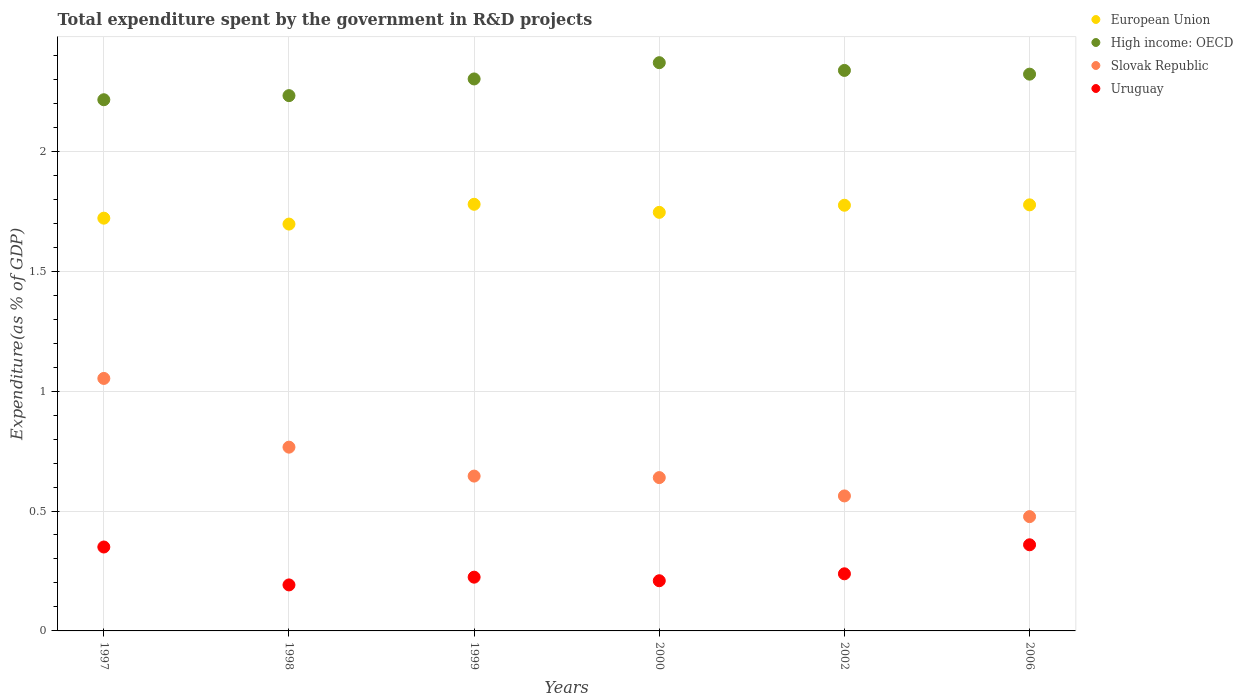Is the number of dotlines equal to the number of legend labels?
Provide a short and direct response. Yes. What is the total expenditure spent by the government in R&D projects in Slovak Republic in 1999?
Offer a very short reply. 0.65. Across all years, what is the maximum total expenditure spent by the government in R&D projects in European Union?
Ensure brevity in your answer.  1.78. Across all years, what is the minimum total expenditure spent by the government in R&D projects in Uruguay?
Keep it short and to the point. 0.19. In which year was the total expenditure spent by the government in R&D projects in Slovak Republic maximum?
Keep it short and to the point. 1997. What is the total total expenditure spent by the government in R&D projects in Slovak Republic in the graph?
Keep it short and to the point. 4.14. What is the difference between the total expenditure spent by the government in R&D projects in European Union in 2002 and that in 2006?
Offer a very short reply. -0. What is the difference between the total expenditure spent by the government in R&D projects in European Union in 2006 and the total expenditure spent by the government in R&D projects in Uruguay in 2002?
Provide a short and direct response. 1.54. What is the average total expenditure spent by the government in R&D projects in Uruguay per year?
Offer a very short reply. 0.26. In the year 2002, what is the difference between the total expenditure spent by the government in R&D projects in Uruguay and total expenditure spent by the government in R&D projects in High income: OECD?
Ensure brevity in your answer.  -2.1. In how many years, is the total expenditure spent by the government in R&D projects in High income: OECD greater than 1.7 %?
Your answer should be compact. 6. What is the ratio of the total expenditure spent by the government in R&D projects in High income: OECD in 1998 to that in 2002?
Make the answer very short. 0.96. Is the total expenditure spent by the government in R&D projects in European Union in 1998 less than that in 2006?
Make the answer very short. Yes. Is the difference between the total expenditure spent by the government in R&D projects in Uruguay in 1999 and 2000 greater than the difference between the total expenditure spent by the government in R&D projects in High income: OECD in 1999 and 2000?
Ensure brevity in your answer.  Yes. What is the difference between the highest and the second highest total expenditure spent by the government in R&D projects in Slovak Republic?
Provide a short and direct response. 0.29. What is the difference between the highest and the lowest total expenditure spent by the government in R&D projects in Slovak Republic?
Provide a short and direct response. 0.58. In how many years, is the total expenditure spent by the government in R&D projects in Slovak Republic greater than the average total expenditure spent by the government in R&D projects in Slovak Republic taken over all years?
Offer a very short reply. 2. Is the sum of the total expenditure spent by the government in R&D projects in Uruguay in 1999 and 2006 greater than the maximum total expenditure spent by the government in R&D projects in Slovak Republic across all years?
Your response must be concise. No. Is it the case that in every year, the sum of the total expenditure spent by the government in R&D projects in Uruguay and total expenditure spent by the government in R&D projects in Slovak Republic  is greater than the total expenditure spent by the government in R&D projects in European Union?
Keep it short and to the point. No. Does the total expenditure spent by the government in R&D projects in High income: OECD monotonically increase over the years?
Provide a short and direct response. No. Is the total expenditure spent by the government in R&D projects in European Union strictly greater than the total expenditure spent by the government in R&D projects in Slovak Republic over the years?
Your answer should be compact. Yes. How many dotlines are there?
Provide a succinct answer. 4. How many years are there in the graph?
Offer a terse response. 6. What is the difference between two consecutive major ticks on the Y-axis?
Give a very brief answer. 0.5. Are the values on the major ticks of Y-axis written in scientific E-notation?
Your answer should be very brief. No. Does the graph contain grids?
Your response must be concise. Yes. Where does the legend appear in the graph?
Provide a succinct answer. Top right. How many legend labels are there?
Make the answer very short. 4. What is the title of the graph?
Offer a terse response. Total expenditure spent by the government in R&D projects. What is the label or title of the Y-axis?
Ensure brevity in your answer.  Expenditure(as % of GDP). What is the Expenditure(as % of GDP) of European Union in 1997?
Offer a terse response. 1.72. What is the Expenditure(as % of GDP) of High income: OECD in 1997?
Offer a very short reply. 2.22. What is the Expenditure(as % of GDP) in Slovak Republic in 1997?
Offer a terse response. 1.05. What is the Expenditure(as % of GDP) in Uruguay in 1997?
Your answer should be very brief. 0.35. What is the Expenditure(as % of GDP) in European Union in 1998?
Make the answer very short. 1.7. What is the Expenditure(as % of GDP) of High income: OECD in 1998?
Your answer should be very brief. 2.23. What is the Expenditure(as % of GDP) of Slovak Republic in 1998?
Your answer should be very brief. 0.77. What is the Expenditure(as % of GDP) of Uruguay in 1998?
Your answer should be compact. 0.19. What is the Expenditure(as % of GDP) in European Union in 1999?
Make the answer very short. 1.78. What is the Expenditure(as % of GDP) of High income: OECD in 1999?
Your answer should be very brief. 2.3. What is the Expenditure(as % of GDP) of Slovak Republic in 1999?
Make the answer very short. 0.65. What is the Expenditure(as % of GDP) of Uruguay in 1999?
Provide a short and direct response. 0.22. What is the Expenditure(as % of GDP) of European Union in 2000?
Ensure brevity in your answer.  1.75. What is the Expenditure(as % of GDP) of High income: OECD in 2000?
Keep it short and to the point. 2.37. What is the Expenditure(as % of GDP) of Slovak Republic in 2000?
Your answer should be compact. 0.64. What is the Expenditure(as % of GDP) of Uruguay in 2000?
Your answer should be compact. 0.21. What is the Expenditure(as % of GDP) in European Union in 2002?
Give a very brief answer. 1.78. What is the Expenditure(as % of GDP) in High income: OECD in 2002?
Offer a very short reply. 2.34. What is the Expenditure(as % of GDP) of Slovak Republic in 2002?
Your answer should be very brief. 0.56. What is the Expenditure(as % of GDP) of Uruguay in 2002?
Your answer should be very brief. 0.24. What is the Expenditure(as % of GDP) in European Union in 2006?
Your answer should be very brief. 1.78. What is the Expenditure(as % of GDP) in High income: OECD in 2006?
Your answer should be very brief. 2.32. What is the Expenditure(as % of GDP) in Slovak Republic in 2006?
Your answer should be very brief. 0.48. What is the Expenditure(as % of GDP) of Uruguay in 2006?
Give a very brief answer. 0.36. Across all years, what is the maximum Expenditure(as % of GDP) of European Union?
Your response must be concise. 1.78. Across all years, what is the maximum Expenditure(as % of GDP) of High income: OECD?
Provide a succinct answer. 2.37. Across all years, what is the maximum Expenditure(as % of GDP) of Slovak Republic?
Make the answer very short. 1.05. Across all years, what is the maximum Expenditure(as % of GDP) in Uruguay?
Your answer should be compact. 0.36. Across all years, what is the minimum Expenditure(as % of GDP) of European Union?
Provide a short and direct response. 1.7. Across all years, what is the minimum Expenditure(as % of GDP) of High income: OECD?
Make the answer very short. 2.22. Across all years, what is the minimum Expenditure(as % of GDP) of Slovak Republic?
Your response must be concise. 0.48. Across all years, what is the minimum Expenditure(as % of GDP) of Uruguay?
Give a very brief answer. 0.19. What is the total Expenditure(as % of GDP) of European Union in the graph?
Keep it short and to the point. 10.49. What is the total Expenditure(as % of GDP) in High income: OECD in the graph?
Your answer should be compact. 13.78. What is the total Expenditure(as % of GDP) of Slovak Republic in the graph?
Provide a succinct answer. 4.14. What is the total Expenditure(as % of GDP) of Uruguay in the graph?
Ensure brevity in your answer.  1.57. What is the difference between the Expenditure(as % of GDP) in European Union in 1997 and that in 1998?
Provide a short and direct response. 0.02. What is the difference between the Expenditure(as % of GDP) in High income: OECD in 1997 and that in 1998?
Offer a very short reply. -0.02. What is the difference between the Expenditure(as % of GDP) of Slovak Republic in 1997 and that in 1998?
Give a very brief answer. 0.29. What is the difference between the Expenditure(as % of GDP) of Uruguay in 1997 and that in 1998?
Make the answer very short. 0.16. What is the difference between the Expenditure(as % of GDP) in European Union in 1997 and that in 1999?
Make the answer very short. -0.06. What is the difference between the Expenditure(as % of GDP) in High income: OECD in 1997 and that in 1999?
Offer a very short reply. -0.09. What is the difference between the Expenditure(as % of GDP) of Slovak Republic in 1997 and that in 1999?
Provide a succinct answer. 0.41. What is the difference between the Expenditure(as % of GDP) of Uruguay in 1997 and that in 1999?
Ensure brevity in your answer.  0.13. What is the difference between the Expenditure(as % of GDP) in European Union in 1997 and that in 2000?
Provide a short and direct response. -0.02. What is the difference between the Expenditure(as % of GDP) in High income: OECD in 1997 and that in 2000?
Provide a succinct answer. -0.15. What is the difference between the Expenditure(as % of GDP) of Slovak Republic in 1997 and that in 2000?
Offer a terse response. 0.41. What is the difference between the Expenditure(as % of GDP) in Uruguay in 1997 and that in 2000?
Offer a terse response. 0.14. What is the difference between the Expenditure(as % of GDP) of European Union in 1997 and that in 2002?
Ensure brevity in your answer.  -0.05. What is the difference between the Expenditure(as % of GDP) of High income: OECD in 1997 and that in 2002?
Ensure brevity in your answer.  -0.12. What is the difference between the Expenditure(as % of GDP) in Slovak Republic in 1997 and that in 2002?
Your response must be concise. 0.49. What is the difference between the Expenditure(as % of GDP) of Uruguay in 1997 and that in 2002?
Ensure brevity in your answer.  0.11. What is the difference between the Expenditure(as % of GDP) in European Union in 1997 and that in 2006?
Your response must be concise. -0.06. What is the difference between the Expenditure(as % of GDP) in High income: OECD in 1997 and that in 2006?
Your answer should be very brief. -0.11. What is the difference between the Expenditure(as % of GDP) of Slovak Republic in 1997 and that in 2006?
Make the answer very short. 0.58. What is the difference between the Expenditure(as % of GDP) of Uruguay in 1997 and that in 2006?
Make the answer very short. -0.01. What is the difference between the Expenditure(as % of GDP) in European Union in 1998 and that in 1999?
Your answer should be compact. -0.08. What is the difference between the Expenditure(as % of GDP) of High income: OECD in 1998 and that in 1999?
Make the answer very short. -0.07. What is the difference between the Expenditure(as % of GDP) in Slovak Republic in 1998 and that in 1999?
Your response must be concise. 0.12. What is the difference between the Expenditure(as % of GDP) in Uruguay in 1998 and that in 1999?
Offer a very short reply. -0.03. What is the difference between the Expenditure(as % of GDP) of European Union in 1998 and that in 2000?
Provide a succinct answer. -0.05. What is the difference between the Expenditure(as % of GDP) in High income: OECD in 1998 and that in 2000?
Give a very brief answer. -0.14. What is the difference between the Expenditure(as % of GDP) in Slovak Republic in 1998 and that in 2000?
Your answer should be compact. 0.13. What is the difference between the Expenditure(as % of GDP) in Uruguay in 1998 and that in 2000?
Provide a succinct answer. -0.02. What is the difference between the Expenditure(as % of GDP) of European Union in 1998 and that in 2002?
Ensure brevity in your answer.  -0.08. What is the difference between the Expenditure(as % of GDP) in High income: OECD in 1998 and that in 2002?
Provide a short and direct response. -0.11. What is the difference between the Expenditure(as % of GDP) of Slovak Republic in 1998 and that in 2002?
Provide a short and direct response. 0.2. What is the difference between the Expenditure(as % of GDP) in Uruguay in 1998 and that in 2002?
Your answer should be compact. -0.05. What is the difference between the Expenditure(as % of GDP) of European Union in 1998 and that in 2006?
Offer a terse response. -0.08. What is the difference between the Expenditure(as % of GDP) of High income: OECD in 1998 and that in 2006?
Offer a very short reply. -0.09. What is the difference between the Expenditure(as % of GDP) of Slovak Republic in 1998 and that in 2006?
Your response must be concise. 0.29. What is the difference between the Expenditure(as % of GDP) in Uruguay in 1998 and that in 2006?
Provide a succinct answer. -0.17. What is the difference between the Expenditure(as % of GDP) of European Union in 1999 and that in 2000?
Provide a succinct answer. 0.03. What is the difference between the Expenditure(as % of GDP) of High income: OECD in 1999 and that in 2000?
Offer a very short reply. -0.07. What is the difference between the Expenditure(as % of GDP) in Slovak Republic in 1999 and that in 2000?
Ensure brevity in your answer.  0.01. What is the difference between the Expenditure(as % of GDP) in Uruguay in 1999 and that in 2000?
Your answer should be compact. 0.01. What is the difference between the Expenditure(as % of GDP) of European Union in 1999 and that in 2002?
Provide a short and direct response. 0. What is the difference between the Expenditure(as % of GDP) in High income: OECD in 1999 and that in 2002?
Make the answer very short. -0.04. What is the difference between the Expenditure(as % of GDP) of Slovak Republic in 1999 and that in 2002?
Ensure brevity in your answer.  0.08. What is the difference between the Expenditure(as % of GDP) in Uruguay in 1999 and that in 2002?
Keep it short and to the point. -0.01. What is the difference between the Expenditure(as % of GDP) of European Union in 1999 and that in 2006?
Your answer should be compact. 0. What is the difference between the Expenditure(as % of GDP) in High income: OECD in 1999 and that in 2006?
Offer a very short reply. -0.02. What is the difference between the Expenditure(as % of GDP) of Slovak Republic in 1999 and that in 2006?
Provide a succinct answer. 0.17. What is the difference between the Expenditure(as % of GDP) in Uruguay in 1999 and that in 2006?
Your response must be concise. -0.14. What is the difference between the Expenditure(as % of GDP) in European Union in 2000 and that in 2002?
Offer a terse response. -0.03. What is the difference between the Expenditure(as % of GDP) in High income: OECD in 2000 and that in 2002?
Make the answer very short. 0.03. What is the difference between the Expenditure(as % of GDP) of Slovak Republic in 2000 and that in 2002?
Your answer should be compact. 0.08. What is the difference between the Expenditure(as % of GDP) of Uruguay in 2000 and that in 2002?
Offer a very short reply. -0.03. What is the difference between the Expenditure(as % of GDP) of European Union in 2000 and that in 2006?
Your response must be concise. -0.03. What is the difference between the Expenditure(as % of GDP) of High income: OECD in 2000 and that in 2006?
Keep it short and to the point. 0.05. What is the difference between the Expenditure(as % of GDP) in Slovak Republic in 2000 and that in 2006?
Provide a short and direct response. 0.16. What is the difference between the Expenditure(as % of GDP) of Uruguay in 2000 and that in 2006?
Provide a succinct answer. -0.15. What is the difference between the Expenditure(as % of GDP) of European Union in 2002 and that in 2006?
Make the answer very short. -0. What is the difference between the Expenditure(as % of GDP) of High income: OECD in 2002 and that in 2006?
Provide a succinct answer. 0.02. What is the difference between the Expenditure(as % of GDP) in Slovak Republic in 2002 and that in 2006?
Keep it short and to the point. 0.09. What is the difference between the Expenditure(as % of GDP) of Uruguay in 2002 and that in 2006?
Offer a very short reply. -0.12. What is the difference between the Expenditure(as % of GDP) in European Union in 1997 and the Expenditure(as % of GDP) in High income: OECD in 1998?
Make the answer very short. -0.51. What is the difference between the Expenditure(as % of GDP) of European Union in 1997 and the Expenditure(as % of GDP) of Slovak Republic in 1998?
Keep it short and to the point. 0.95. What is the difference between the Expenditure(as % of GDP) of European Union in 1997 and the Expenditure(as % of GDP) of Uruguay in 1998?
Provide a short and direct response. 1.53. What is the difference between the Expenditure(as % of GDP) in High income: OECD in 1997 and the Expenditure(as % of GDP) in Slovak Republic in 1998?
Provide a succinct answer. 1.45. What is the difference between the Expenditure(as % of GDP) in High income: OECD in 1997 and the Expenditure(as % of GDP) in Uruguay in 1998?
Your answer should be very brief. 2.02. What is the difference between the Expenditure(as % of GDP) of Slovak Republic in 1997 and the Expenditure(as % of GDP) of Uruguay in 1998?
Keep it short and to the point. 0.86. What is the difference between the Expenditure(as % of GDP) in European Union in 1997 and the Expenditure(as % of GDP) in High income: OECD in 1999?
Give a very brief answer. -0.58. What is the difference between the Expenditure(as % of GDP) in European Union in 1997 and the Expenditure(as % of GDP) in Slovak Republic in 1999?
Give a very brief answer. 1.08. What is the difference between the Expenditure(as % of GDP) in European Union in 1997 and the Expenditure(as % of GDP) in Uruguay in 1999?
Give a very brief answer. 1.5. What is the difference between the Expenditure(as % of GDP) in High income: OECD in 1997 and the Expenditure(as % of GDP) in Slovak Republic in 1999?
Provide a succinct answer. 1.57. What is the difference between the Expenditure(as % of GDP) of High income: OECD in 1997 and the Expenditure(as % of GDP) of Uruguay in 1999?
Offer a terse response. 1.99. What is the difference between the Expenditure(as % of GDP) of Slovak Republic in 1997 and the Expenditure(as % of GDP) of Uruguay in 1999?
Your answer should be compact. 0.83. What is the difference between the Expenditure(as % of GDP) in European Union in 1997 and the Expenditure(as % of GDP) in High income: OECD in 2000?
Give a very brief answer. -0.65. What is the difference between the Expenditure(as % of GDP) of European Union in 1997 and the Expenditure(as % of GDP) of Slovak Republic in 2000?
Keep it short and to the point. 1.08. What is the difference between the Expenditure(as % of GDP) in European Union in 1997 and the Expenditure(as % of GDP) in Uruguay in 2000?
Your answer should be very brief. 1.51. What is the difference between the Expenditure(as % of GDP) in High income: OECD in 1997 and the Expenditure(as % of GDP) in Slovak Republic in 2000?
Provide a short and direct response. 1.58. What is the difference between the Expenditure(as % of GDP) of High income: OECD in 1997 and the Expenditure(as % of GDP) of Uruguay in 2000?
Provide a short and direct response. 2.01. What is the difference between the Expenditure(as % of GDP) in Slovak Republic in 1997 and the Expenditure(as % of GDP) in Uruguay in 2000?
Keep it short and to the point. 0.84. What is the difference between the Expenditure(as % of GDP) of European Union in 1997 and the Expenditure(as % of GDP) of High income: OECD in 2002?
Offer a terse response. -0.62. What is the difference between the Expenditure(as % of GDP) of European Union in 1997 and the Expenditure(as % of GDP) of Slovak Republic in 2002?
Offer a terse response. 1.16. What is the difference between the Expenditure(as % of GDP) of European Union in 1997 and the Expenditure(as % of GDP) of Uruguay in 2002?
Your answer should be very brief. 1.48. What is the difference between the Expenditure(as % of GDP) in High income: OECD in 1997 and the Expenditure(as % of GDP) in Slovak Republic in 2002?
Keep it short and to the point. 1.65. What is the difference between the Expenditure(as % of GDP) in High income: OECD in 1997 and the Expenditure(as % of GDP) in Uruguay in 2002?
Keep it short and to the point. 1.98. What is the difference between the Expenditure(as % of GDP) of Slovak Republic in 1997 and the Expenditure(as % of GDP) of Uruguay in 2002?
Ensure brevity in your answer.  0.81. What is the difference between the Expenditure(as % of GDP) of European Union in 1997 and the Expenditure(as % of GDP) of High income: OECD in 2006?
Provide a succinct answer. -0.6. What is the difference between the Expenditure(as % of GDP) in European Union in 1997 and the Expenditure(as % of GDP) in Slovak Republic in 2006?
Keep it short and to the point. 1.24. What is the difference between the Expenditure(as % of GDP) of European Union in 1997 and the Expenditure(as % of GDP) of Uruguay in 2006?
Offer a very short reply. 1.36. What is the difference between the Expenditure(as % of GDP) of High income: OECD in 1997 and the Expenditure(as % of GDP) of Slovak Republic in 2006?
Offer a terse response. 1.74. What is the difference between the Expenditure(as % of GDP) of High income: OECD in 1997 and the Expenditure(as % of GDP) of Uruguay in 2006?
Offer a very short reply. 1.86. What is the difference between the Expenditure(as % of GDP) in Slovak Republic in 1997 and the Expenditure(as % of GDP) in Uruguay in 2006?
Give a very brief answer. 0.69. What is the difference between the Expenditure(as % of GDP) of European Union in 1998 and the Expenditure(as % of GDP) of High income: OECD in 1999?
Your response must be concise. -0.61. What is the difference between the Expenditure(as % of GDP) in European Union in 1998 and the Expenditure(as % of GDP) in Slovak Republic in 1999?
Provide a short and direct response. 1.05. What is the difference between the Expenditure(as % of GDP) in European Union in 1998 and the Expenditure(as % of GDP) in Uruguay in 1999?
Your response must be concise. 1.47. What is the difference between the Expenditure(as % of GDP) of High income: OECD in 1998 and the Expenditure(as % of GDP) of Slovak Republic in 1999?
Your answer should be compact. 1.59. What is the difference between the Expenditure(as % of GDP) in High income: OECD in 1998 and the Expenditure(as % of GDP) in Uruguay in 1999?
Offer a terse response. 2.01. What is the difference between the Expenditure(as % of GDP) in Slovak Republic in 1998 and the Expenditure(as % of GDP) in Uruguay in 1999?
Your response must be concise. 0.54. What is the difference between the Expenditure(as % of GDP) of European Union in 1998 and the Expenditure(as % of GDP) of High income: OECD in 2000?
Offer a very short reply. -0.67. What is the difference between the Expenditure(as % of GDP) of European Union in 1998 and the Expenditure(as % of GDP) of Slovak Republic in 2000?
Ensure brevity in your answer.  1.06. What is the difference between the Expenditure(as % of GDP) in European Union in 1998 and the Expenditure(as % of GDP) in Uruguay in 2000?
Offer a terse response. 1.49. What is the difference between the Expenditure(as % of GDP) of High income: OECD in 1998 and the Expenditure(as % of GDP) of Slovak Republic in 2000?
Provide a short and direct response. 1.59. What is the difference between the Expenditure(as % of GDP) of High income: OECD in 1998 and the Expenditure(as % of GDP) of Uruguay in 2000?
Provide a short and direct response. 2.02. What is the difference between the Expenditure(as % of GDP) of Slovak Republic in 1998 and the Expenditure(as % of GDP) of Uruguay in 2000?
Provide a short and direct response. 0.56. What is the difference between the Expenditure(as % of GDP) of European Union in 1998 and the Expenditure(as % of GDP) of High income: OECD in 2002?
Your answer should be very brief. -0.64. What is the difference between the Expenditure(as % of GDP) of European Union in 1998 and the Expenditure(as % of GDP) of Slovak Republic in 2002?
Your answer should be very brief. 1.13. What is the difference between the Expenditure(as % of GDP) in European Union in 1998 and the Expenditure(as % of GDP) in Uruguay in 2002?
Give a very brief answer. 1.46. What is the difference between the Expenditure(as % of GDP) of High income: OECD in 1998 and the Expenditure(as % of GDP) of Slovak Republic in 2002?
Provide a succinct answer. 1.67. What is the difference between the Expenditure(as % of GDP) in High income: OECD in 1998 and the Expenditure(as % of GDP) in Uruguay in 2002?
Offer a terse response. 1.99. What is the difference between the Expenditure(as % of GDP) in Slovak Republic in 1998 and the Expenditure(as % of GDP) in Uruguay in 2002?
Your response must be concise. 0.53. What is the difference between the Expenditure(as % of GDP) in European Union in 1998 and the Expenditure(as % of GDP) in High income: OECD in 2006?
Keep it short and to the point. -0.63. What is the difference between the Expenditure(as % of GDP) of European Union in 1998 and the Expenditure(as % of GDP) of Slovak Republic in 2006?
Keep it short and to the point. 1.22. What is the difference between the Expenditure(as % of GDP) of European Union in 1998 and the Expenditure(as % of GDP) of Uruguay in 2006?
Your response must be concise. 1.34. What is the difference between the Expenditure(as % of GDP) of High income: OECD in 1998 and the Expenditure(as % of GDP) of Slovak Republic in 2006?
Give a very brief answer. 1.76. What is the difference between the Expenditure(as % of GDP) of High income: OECD in 1998 and the Expenditure(as % of GDP) of Uruguay in 2006?
Ensure brevity in your answer.  1.87. What is the difference between the Expenditure(as % of GDP) of Slovak Republic in 1998 and the Expenditure(as % of GDP) of Uruguay in 2006?
Offer a terse response. 0.41. What is the difference between the Expenditure(as % of GDP) of European Union in 1999 and the Expenditure(as % of GDP) of High income: OECD in 2000?
Offer a terse response. -0.59. What is the difference between the Expenditure(as % of GDP) of European Union in 1999 and the Expenditure(as % of GDP) of Slovak Republic in 2000?
Ensure brevity in your answer.  1.14. What is the difference between the Expenditure(as % of GDP) of European Union in 1999 and the Expenditure(as % of GDP) of Uruguay in 2000?
Keep it short and to the point. 1.57. What is the difference between the Expenditure(as % of GDP) of High income: OECD in 1999 and the Expenditure(as % of GDP) of Slovak Republic in 2000?
Offer a terse response. 1.66. What is the difference between the Expenditure(as % of GDP) in High income: OECD in 1999 and the Expenditure(as % of GDP) in Uruguay in 2000?
Your answer should be compact. 2.09. What is the difference between the Expenditure(as % of GDP) of Slovak Republic in 1999 and the Expenditure(as % of GDP) of Uruguay in 2000?
Offer a terse response. 0.44. What is the difference between the Expenditure(as % of GDP) in European Union in 1999 and the Expenditure(as % of GDP) in High income: OECD in 2002?
Make the answer very short. -0.56. What is the difference between the Expenditure(as % of GDP) of European Union in 1999 and the Expenditure(as % of GDP) of Slovak Republic in 2002?
Offer a terse response. 1.22. What is the difference between the Expenditure(as % of GDP) of European Union in 1999 and the Expenditure(as % of GDP) of Uruguay in 2002?
Provide a short and direct response. 1.54. What is the difference between the Expenditure(as % of GDP) of High income: OECD in 1999 and the Expenditure(as % of GDP) of Slovak Republic in 2002?
Provide a short and direct response. 1.74. What is the difference between the Expenditure(as % of GDP) of High income: OECD in 1999 and the Expenditure(as % of GDP) of Uruguay in 2002?
Ensure brevity in your answer.  2.06. What is the difference between the Expenditure(as % of GDP) in Slovak Republic in 1999 and the Expenditure(as % of GDP) in Uruguay in 2002?
Ensure brevity in your answer.  0.41. What is the difference between the Expenditure(as % of GDP) in European Union in 1999 and the Expenditure(as % of GDP) in High income: OECD in 2006?
Your response must be concise. -0.54. What is the difference between the Expenditure(as % of GDP) of European Union in 1999 and the Expenditure(as % of GDP) of Slovak Republic in 2006?
Offer a terse response. 1.3. What is the difference between the Expenditure(as % of GDP) of European Union in 1999 and the Expenditure(as % of GDP) of Uruguay in 2006?
Give a very brief answer. 1.42. What is the difference between the Expenditure(as % of GDP) of High income: OECD in 1999 and the Expenditure(as % of GDP) of Slovak Republic in 2006?
Keep it short and to the point. 1.83. What is the difference between the Expenditure(as % of GDP) in High income: OECD in 1999 and the Expenditure(as % of GDP) in Uruguay in 2006?
Give a very brief answer. 1.94. What is the difference between the Expenditure(as % of GDP) in Slovak Republic in 1999 and the Expenditure(as % of GDP) in Uruguay in 2006?
Make the answer very short. 0.29. What is the difference between the Expenditure(as % of GDP) of European Union in 2000 and the Expenditure(as % of GDP) of High income: OECD in 2002?
Your response must be concise. -0.59. What is the difference between the Expenditure(as % of GDP) in European Union in 2000 and the Expenditure(as % of GDP) in Slovak Republic in 2002?
Offer a terse response. 1.18. What is the difference between the Expenditure(as % of GDP) of European Union in 2000 and the Expenditure(as % of GDP) of Uruguay in 2002?
Keep it short and to the point. 1.51. What is the difference between the Expenditure(as % of GDP) in High income: OECD in 2000 and the Expenditure(as % of GDP) in Slovak Republic in 2002?
Make the answer very short. 1.81. What is the difference between the Expenditure(as % of GDP) in High income: OECD in 2000 and the Expenditure(as % of GDP) in Uruguay in 2002?
Your response must be concise. 2.13. What is the difference between the Expenditure(as % of GDP) in Slovak Republic in 2000 and the Expenditure(as % of GDP) in Uruguay in 2002?
Provide a succinct answer. 0.4. What is the difference between the Expenditure(as % of GDP) of European Union in 2000 and the Expenditure(as % of GDP) of High income: OECD in 2006?
Offer a very short reply. -0.58. What is the difference between the Expenditure(as % of GDP) of European Union in 2000 and the Expenditure(as % of GDP) of Slovak Republic in 2006?
Provide a short and direct response. 1.27. What is the difference between the Expenditure(as % of GDP) in European Union in 2000 and the Expenditure(as % of GDP) in Uruguay in 2006?
Offer a terse response. 1.39. What is the difference between the Expenditure(as % of GDP) of High income: OECD in 2000 and the Expenditure(as % of GDP) of Slovak Republic in 2006?
Give a very brief answer. 1.89. What is the difference between the Expenditure(as % of GDP) in High income: OECD in 2000 and the Expenditure(as % of GDP) in Uruguay in 2006?
Your answer should be very brief. 2.01. What is the difference between the Expenditure(as % of GDP) in Slovak Republic in 2000 and the Expenditure(as % of GDP) in Uruguay in 2006?
Your response must be concise. 0.28. What is the difference between the Expenditure(as % of GDP) in European Union in 2002 and the Expenditure(as % of GDP) in High income: OECD in 2006?
Provide a short and direct response. -0.55. What is the difference between the Expenditure(as % of GDP) in European Union in 2002 and the Expenditure(as % of GDP) in Slovak Republic in 2006?
Make the answer very short. 1.3. What is the difference between the Expenditure(as % of GDP) in European Union in 2002 and the Expenditure(as % of GDP) in Uruguay in 2006?
Your answer should be compact. 1.42. What is the difference between the Expenditure(as % of GDP) in High income: OECD in 2002 and the Expenditure(as % of GDP) in Slovak Republic in 2006?
Offer a very short reply. 1.86. What is the difference between the Expenditure(as % of GDP) in High income: OECD in 2002 and the Expenditure(as % of GDP) in Uruguay in 2006?
Offer a very short reply. 1.98. What is the difference between the Expenditure(as % of GDP) of Slovak Republic in 2002 and the Expenditure(as % of GDP) of Uruguay in 2006?
Keep it short and to the point. 0.2. What is the average Expenditure(as % of GDP) in European Union per year?
Your response must be concise. 1.75. What is the average Expenditure(as % of GDP) in High income: OECD per year?
Provide a succinct answer. 2.3. What is the average Expenditure(as % of GDP) in Slovak Republic per year?
Provide a succinct answer. 0.69. What is the average Expenditure(as % of GDP) of Uruguay per year?
Provide a succinct answer. 0.26. In the year 1997, what is the difference between the Expenditure(as % of GDP) of European Union and Expenditure(as % of GDP) of High income: OECD?
Keep it short and to the point. -0.49. In the year 1997, what is the difference between the Expenditure(as % of GDP) of European Union and Expenditure(as % of GDP) of Slovak Republic?
Provide a short and direct response. 0.67. In the year 1997, what is the difference between the Expenditure(as % of GDP) in European Union and Expenditure(as % of GDP) in Uruguay?
Your response must be concise. 1.37. In the year 1997, what is the difference between the Expenditure(as % of GDP) of High income: OECD and Expenditure(as % of GDP) of Slovak Republic?
Offer a terse response. 1.16. In the year 1997, what is the difference between the Expenditure(as % of GDP) in High income: OECD and Expenditure(as % of GDP) in Uruguay?
Give a very brief answer. 1.87. In the year 1997, what is the difference between the Expenditure(as % of GDP) in Slovak Republic and Expenditure(as % of GDP) in Uruguay?
Offer a terse response. 0.7. In the year 1998, what is the difference between the Expenditure(as % of GDP) of European Union and Expenditure(as % of GDP) of High income: OECD?
Offer a very short reply. -0.54. In the year 1998, what is the difference between the Expenditure(as % of GDP) of European Union and Expenditure(as % of GDP) of Slovak Republic?
Give a very brief answer. 0.93. In the year 1998, what is the difference between the Expenditure(as % of GDP) of European Union and Expenditure(as % of GDP) of Uruguay?
Keep it short and to the point. 1.5. In the year 1998, what is the difference between the Expenditure(as % of GDP) in High income: OECD and Expenditure(as % of GDP) in Slovak Republic?
Your response must be concise. 1.47. In the year 1998, what is the difference between the Expenditure(as % of GDP) of High income: OECD and Expenditure(as % of GDP) of Uruguay?
Provide a succinct answer. 2.04. In the year 1998, what is the difference between the Expenditure(as % of GDP) in Slovak Republic and Expenditure(as % of GDP) in Uruguay?
Your answer should be compact. 0.57. In the year 1999, what is the difference between the Expenditure(as % of GDP) in European Union and Expenditure(as % of GDP) in High income: OECD?
Make the answer very short. -0.52. In the year 1999, what is the difference between the Expenditure(as % of GDP) of European Union and Expenditure(as % of GDP) of Slovak Republic?
Make the answer very short. 1.13. In the year 1999, what is the difference between the Expenditure(as % of GDP) of European Union and Expenditure(as % of GDP) of Uruguay?
Make the answer very short. 1.55. In the year 1999, what is the difference between the Expenditure(as % of GDP) of High income: OECD and Expenditure(as % of GDP) of Slovak Republic?
Your response must be concise. 1.66. In the year 1999, what is the difference between the Expenditure(as % of GDP) of High income: OECD and Expenditure(as % of GDP) of Uruguay?
Make the answer very short. 2.08. In the year 1999, what is the difference between the Expenditure(as % of GDP) in Slovak Republic and Expenditure(as % of GDP) in Uruguay?
Give a very brief answer. 0.42. In the year 2000, what is the difference between the Expenditure(as % of GDP) in European Union and Expenditure(as % of GDP) in High income: OECD?
Ensure brevity in your answer.  -0.62. In the year 2000, what is the difference between the Expenditure(as % of GDP) of European Union and Expenditure(as % of GDP) of Slovak Republic?
Ensure brevity in your answer.  1.11. In the year 2000, what is the difference between the Expenditure(as % of GDP) of European Union and Expenditure(as % of GDP) of Uruguay?
Your response must be concise. 1.54. In the year 2000, what is the difference between the Expenditure(as % of GDP) of High income: OECD and Expenditure(as % of GDP) of Slovak Republic?
Make the answer very short. 1.73. In the year 2000, what is the difference between the Expenditure(as % of GDP) in High income: OECD and Expenditure(as % of GDP) in Uruguay?
Ensure brevity in your answer.  2.16. In the year 2000, what is the difference between the Expenditure(as % of GDP) in Slovak Republic and Expenditure(as % of GDP) in Uruguay?
Your response must be concise. 0.43. In the year 2002, what is the difference between the Expenditure(as % of GDP) of European Union and Expenditure(as % of GDP) of High income: OECD?
Your answer should be very brief. -0.56. In the year 2002, what is the difference between the Expenditure(as % of GDP) of European Union and Expenditure(as % of GDP) of Slovak Republic?
Make the answer very short. 1.21. In the year 2002, what is the difference between the Expenditure(as % of GDP) of European Union and Expenditure(as % of GDP) of Uruguay?
Offer a very short reply. 1.54. In the year 2002, what is the difference between the Expenditure(as % of GDP) in High income: OECD and Expenditure(as % of GDP) in Slovak Republic?
Your answer should be very brief. 1.77. In the year 2002, what is the difference between the Expenditure(as % of GDP) of High income: OECD and Expenditure(as % of GDP) of Uruguay?
Your answer should be compact. 2.1. In the year 2002, what is the difference between the Expenditure(as % of GDP) in Slovak Republic and Expenditure(as % of GDP) in Uruguay?
Offer a very short reply. 0.32. In the year 2006, what is the difference between the Expenditure(as % of GDP) of European Union and Expenditure(as % of GDP) of High income: OECD?
Ensure brevity in your answer.  -0.55. In the year 2006, what is the difference between the Expenditure(as % of GDP) in European Union and Expenditure(as % of GDP) in Slovak Republic?
Make the answer very short. 1.3. In the year 2006, what is the difference between the Expenditure(as % of GDP) of European Union and Expenditure(as % of GDP) of Uruguay?
Provide a succinct answer. 1.42. In the year 2006, what is the difference between the Expenditure(as % of GDP) in High income: OECD and Expenditure(as % of GDP) in Slovak Republic?
Your answer should be very brief. 1.85. In the year 2006, what is the difference between the Expenditure(as % of GDP) in High income: OECD and Expenditure(as % of GDP) in Uruguay?
Offer a very short reply. 1.96. In the year 2006, what is the difference between the Expenditure(as % of GDP) in Slovak Republic and Expenditure(as % of GDP) in Uruguay?
Provide a short and direct response. 0.12. What is the ratio of the Expenditure(as % of GDP) of European Union in 1997 to that in 1998?
Your response must be concise. 1.01. What is the ratio of the Expenditure(as % of GDP) in High income: OECD in 1997 to that in 1998?
Offer a terse response. 0.99. What is the ratio of the Expenditure(as % of GDP) of Slovak Republic in 1997 to that in 1998?
Offer a very short reply. 1.37. What is the ratio of the Expenditure(as % of GDP) of Uruguay in 1997 to that in 1998?
Make the answer very short. 1.82. What is the ratio of the Expenditure(as % of GDP) in European Union in 1997 to that in 1999?
Provide a succinct answer. 0.97. What is the ratio of the Expenditure(as % of GDP) in High income: OECD in 1997 to that in 1999?
Offer a very short reply. 0.96. What is the ratio of the Expenditure(as % of GDP) of Slovak Republic in 1997 to that in 1999?
Keep it short and to the point. 1.63. What is the ratio of the Expenditure(as % of GDP) of Uruguay in 1997 to that in 1999?
Provide a short and direct response. 1.56. What is the ratio of the Expenditure(as % of GDP) in European Union in 1997 to that in 2000?
Offer a very short reply. 0.99. What is the ratio of the Expenditure(as % of GDP) in High income: OECD in 1997 to that in 2000?
Offer a terse response. 0.93. What is the ratio of the Expenditure(as % of GDP) of Slovak Republic in 1997 to that in 2000?
Your answer should be compact. 1.65. What is the ratio of the Expenditure(as % of GDP) of Uruguay in 1997 to that in 2000?
Your response must be concise. 1.67. What is the ratio of the Expenditure(as % of GDP) in European Union in 1997 to that in 2002?
Offer a terse response. 0.97. What is the ratio of the Expenditure(as % of GDP) in High income: OECD in 1997 to that in 2002?
Your answer should be very brief. 0.95. What is the ratio of the Expenditure(as % of GDP) in Slovak Republic in 1997 to that in 2002?
Offer a very short reply. 1.87. What is the ratio of the Expenditure(as % of GDP) in Uruguay in 1997 to that in 2002?
Your answer should be compact. 1.47. What is the ratio of the Expenditure(as % of GDP) in European Union in 1997 to that in 2006?
Offer a very short reply. 0.97. What is the ratio of the Expenditure(as % of GDP) of High income: OECD in 1997 to that in 2006?
Make the answer very short. 0.95. What is the ratio of the Expenditure(as % of GDP) in Slovak Republic in 1997 to that in 2006?
Your answer should be very brief. 2.21. What is the ratio of the Expenditure(as % of GDP) in Uruguay in 1997 to that in 2006?
Offer a very short reply. 0.97. What is the ratio of the Expenditure(as % of GDP) in European Union in 1998 to that in 1999?
Your response must be concise. 0.95. What is the ratio of the Expenditure(as % of GDP) of High income: OECD in 1998 to that in 1999?
Give a very brief answer. 0.97. What is the ratio of the Expenditure(as % of GDP) in Slovak Republic in 1998 to that in 1999?
Your response must be concise. 1.19. What is the ratio of the Expenditure(as % of GDP) of Uruguay in 1998 to that in 1999?
Your answer should be very brief. 0.86. What is the ratio of the Expenditure(as % of GDP) of High income: OECD in 1998 to that in 2000?
Provide a succinct answer. 0.94. What is the ratio of the Expenditure(as % of GDP) in Slovak Republic in 1998 to that in 2000?
Offer a terse response. 1.2. What is the ratio of the Expenditure(as % of GDP) in Uruguay in 1998 to that in 2000?
Your answer should be compact. 0.92. What is the ratio of the Expenditure(as % of GDP) in European Union in 1998 to that in 2002?
Offer a very short reply. 0.96. What is the ratio of the Expenditure(as % of GDP) in High income: OECD in 1998 to that in 2002?
Provide a succinct answer. 0.95. What is the ratio of the Expenditure(as % of GDP) in Slovak Republic in 1998 to that in 2002?
Offer a terse response. 1.36. What is the ratio of the Expenditure(as % of GDP) in Uruguay in 1998 to that in 2002?
Offer a terse response. 0.81. What is the ratio of the Expenditure(as % of GDP) in European Union in 1998 to that in 2006?
Keep it short and to the point. 0.95. What is the ratio of the Expenditure(as % of GDP) in High income: OECD in 1998 to that in 2006?
Your response must be concise. 0.96. What is the ratio of the Expenditure(as % of GDP) of Slovak Republic in 1998 to that in 2006?
Ensure brevity in your answer.  1.61. What is the ratio of the Expenditure(as % of GDP) of Uruguay in 1998 to that in 2006?
Keep it short and to the point. 0.53. What is the ratio of the Expenditure(as % of GDP) in European Union in 1999 to that in 2000?
Your response must be concise. 1.02. What is the ratio of the Expenditure(as % of GDP) in High income: OECD in 1999 to that in 2000?
Offer a very short reply. 0.97. What is the ratio of the Expenditure(as % of GDP) in Slovak Republic in 1999 to that in 2000?
Offer a very short reply. 1.01. What is the ratio of the Expenditure(as % of GDP) of Uruguay in 1999 to that in 2000?
Provide a succinct answer. 1.07. What is the ratio of the Expenditure(as % of GDP) in High income: OECD in 1999 to that in 2002?
Offer a terse response. 0.98. What is the ratio of the Expenditure(as % of GDP) of Slovak Republic in 1999 to that in 2002?
Keep it short and to the point. 1.15. What is the ratio of the Expenditure(as % of GDP) of High income: OECD in 1999 to that in 2006?
Provide a succinct answer. 0.99. What is the ratio of the Expenditure(as % of GDP) of Slovak Republic in 1999 to that in 2006?
Your answer should be very brief. 1.35. What is the ratio of the Expenditure(as % of GDP) of Uruguay in 1999 to that in 2006?
Provide a short and direct response. 0.62. What is the ratio of the Expenditure(as % of GDP) of European Union in 2000 to that in 2002?
Provide a short and direct response. 0.98. What is the ratio of the Expenditure(as % of GDP) of High income: OECD in 2000 to that in 2002?
Your answer should be very brief. 1.01. What is the ratio of the Expenditure(as % of GDP) in Slovak Republic in 2000 to that in 2002?
Keep it short and to the point. 1.14. What is the ratio of the Expenditure(as % of GDP) in Uruguay in 2000 to that in 2002?
Give a very brief answer. 0.88. What is the ratio of the Expenditure(as % of GDP) of European Union in 2000 to that in 2006?
Give a very brief answer. 0.98. What is the ratio of the Expenditure(as % of GDP) in High income: OECD in 2000 to that in 2006?
Keep it short and to the point. 1.02. What is the ratio of the Expenditure(as % of GDP) in Slovak Republic in 2000 to that in 2006?
Offer a very short reply. 1.34. What is the ratio of the Expenditure(as % of GDP) of Uruguay in 2000 to that in 2006?
Provide a short and direct response. 0.58. What is the ratio of the Expenditure(as % of GDP) of High income: OECD in 2002 to that in 2006?
Make the answer very short. 1.01. What is the ratio of the Expenditure(as % of GDP) in Slovak Republic in 2002 to that in 2006?
Your response must be concise. 1.18. What is the ratio of the Expenditure(as % of GDP) in Uruguay in 2002 to that in 2006?
Your answer should be very brief. 0.66. What is the difference between the highest and the second highest Expenditure(as % of GDP) in European Union?
Your answer should be very brief. 0. What is the difference between the highest and the second highest Expenditure(as % of GDP) in High income: OECD?
Provide a succinct answer. 0.03. What is the difference between the highest and the second highest Expenditure(as % of GDP) in Slovak Republic?
Provide a succinct answer. 0.29. What is the difference between the highest and the second highest Expenditure(as % of GDP) of Uruguay?
Your response must be concise. 0.01. What is the difference between the highest and the lowest Expenditure(as % of GDP) of European Union?
Your response must be concise. 0.08. What is the difference between the highest and the lowest Expenditure(as % of GDP) in High income: OECD?
Give a very brief answer. 0.15. What is the difference between the highest and the lowest Expenditure(as % of GDP) in Slovak Republic?
Offer a terse response. 0.58. What is the difference between the highest and the lowest Expenditure(as % of GDP) of Uruguay?
Ensure brevity in your answer.  0.17. 